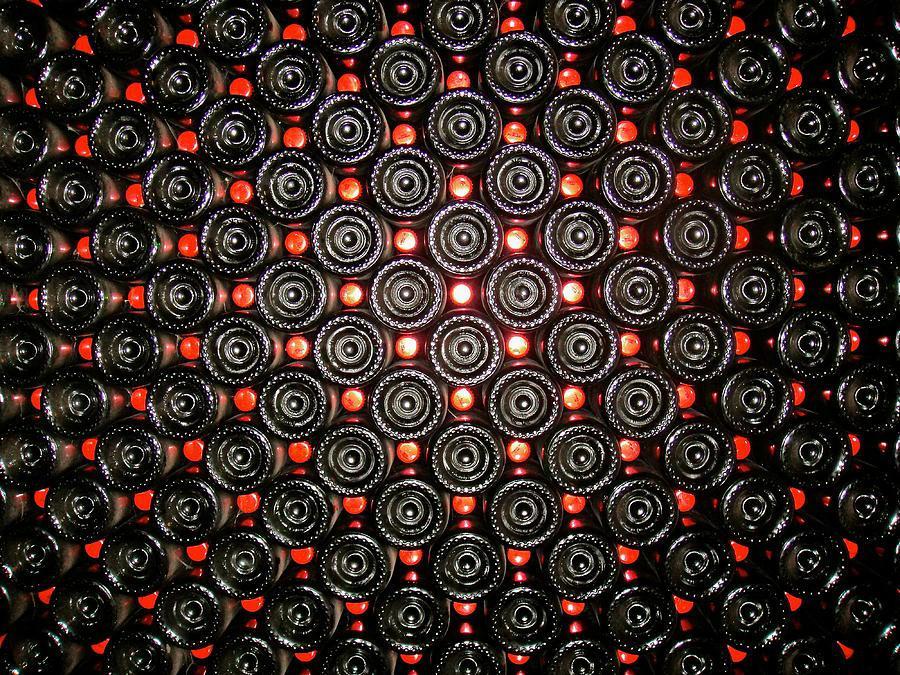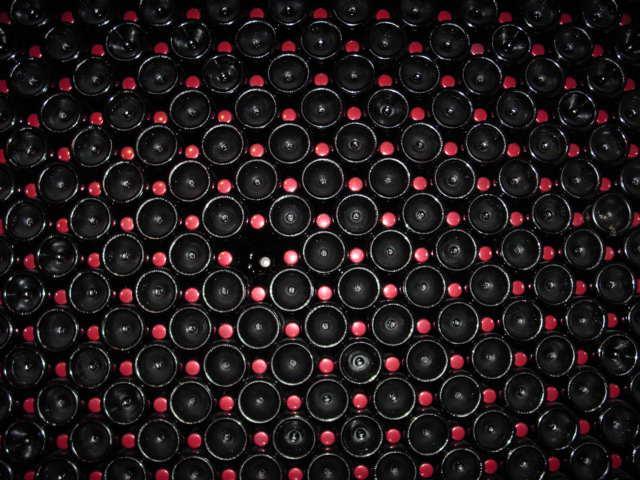The first image is the image on the left, the second image is the image on the right. Considering the images on both sides, is "A single bottle and glass of wine are in one of the images." valid? Answer yes or no. No. The first image is the image on the left, the second image is the image on the right. Assess this claim about the two images: "There is a glass of red wine next to a bottle of wine in one of the images". Correct or not? Answer yes or no. No. 